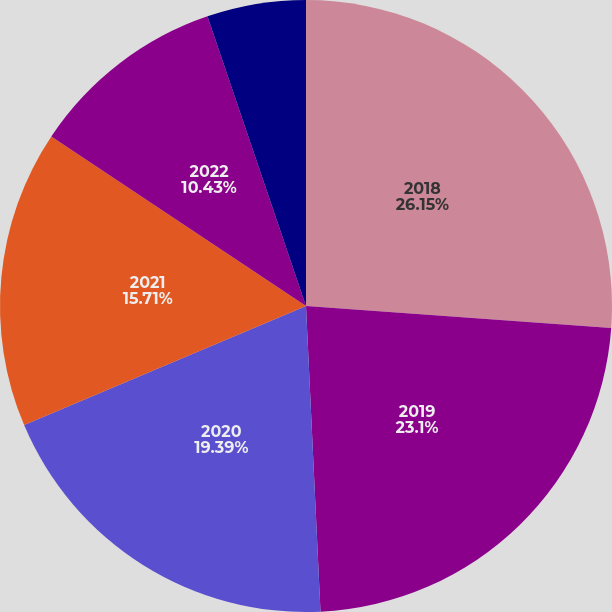Convert chart. <chart><loc_0><loc_0><loc_500><loc_500><pie_chart><fcel>2018<fcel>2019<fcel>2020<fcel>2021<fcel>2022<fcel>2023 and thereafter<nl><fcel>26.14%<fcel>23.1%<fcel>19.39%<fcel>15.71%<fcel>10.43%<fcel>5.22%<nl></chart> 